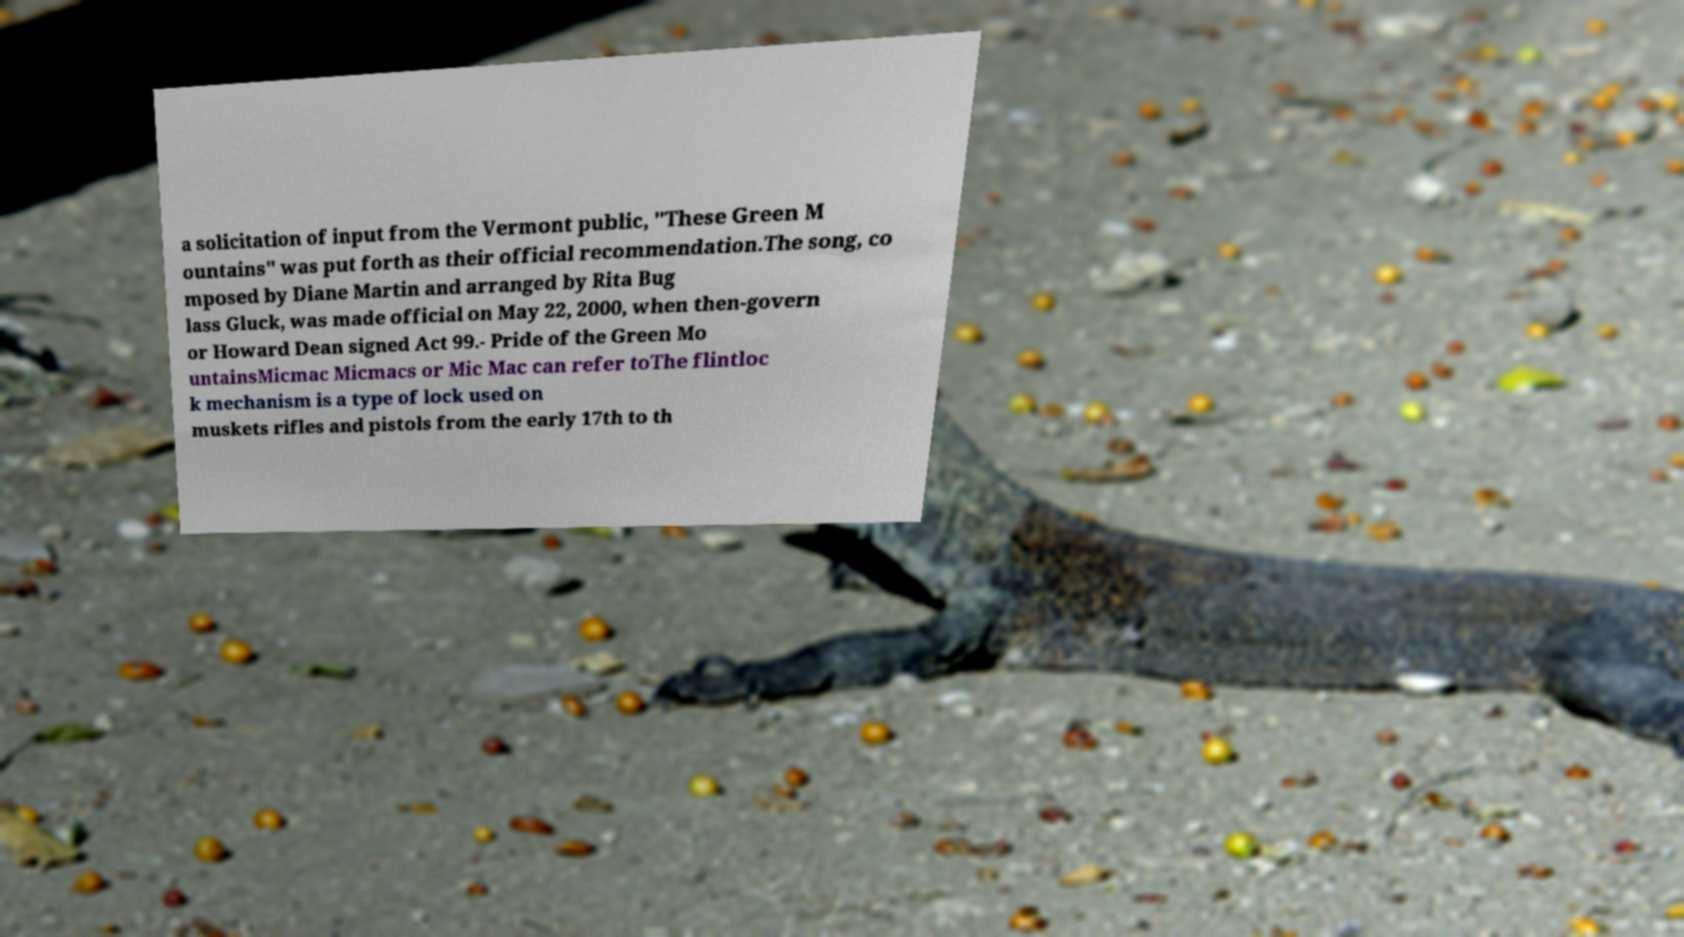I need the written content from this picture converted into text. Can you do that? a solicitation of input from the Vermont public, "These Green M ountains" was put forth as their official recommendation.The song, co mposed by Diane Martin and arranged by Rita Bug lass Gluck, was made official on May 22, 2000, when then-govern or Howard Dean signed Act 99.- Pride of the Green Mo untainsMicmac Micmacs or Mic Mac can refer toThe flintloc k mechanism is a type of lock used on muskets rifles and pistols from the early 17th to th 